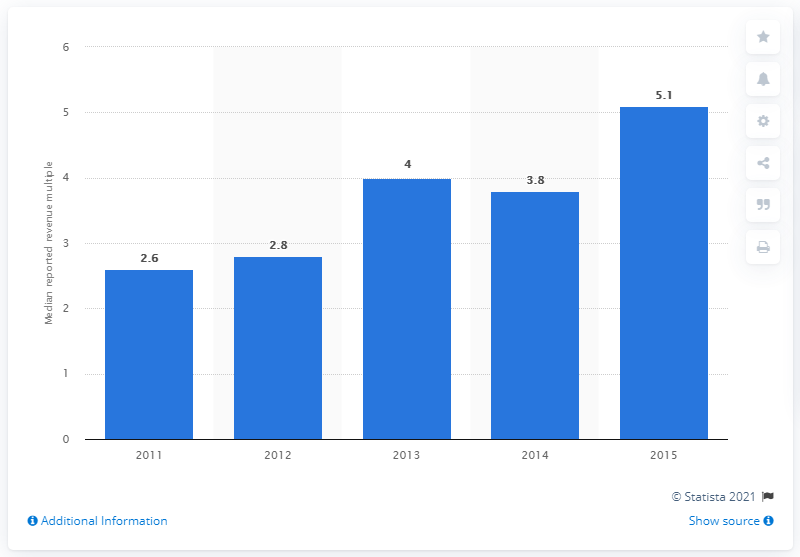Highlight a few significant elements in this photo. The median M&A value to revenue multiple in 2015 was 5.1. 